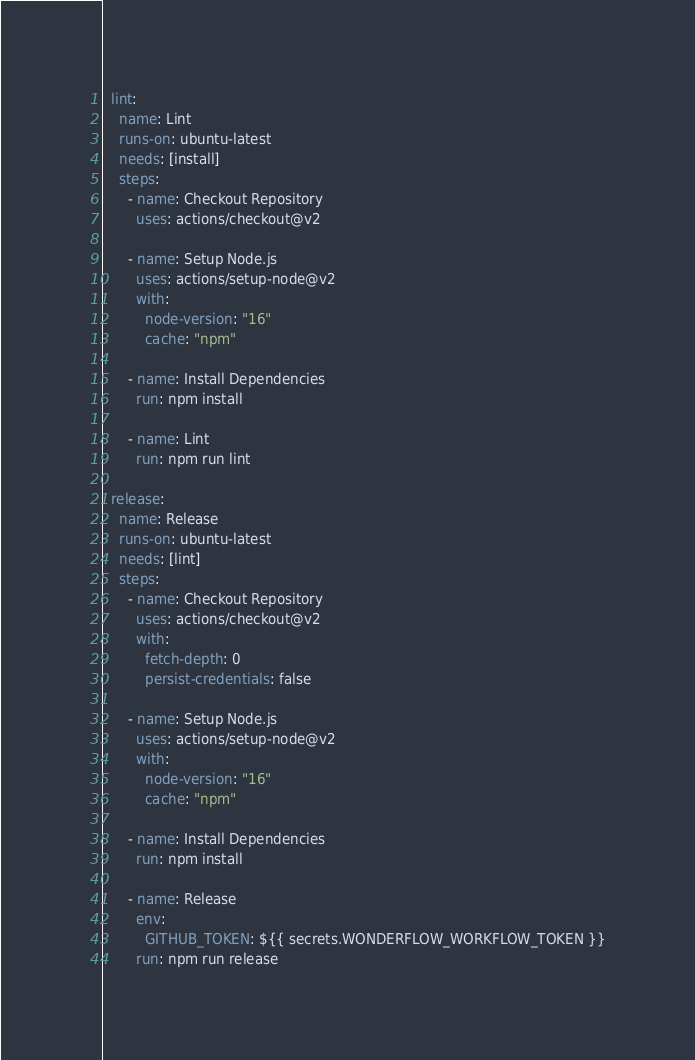<code> <loc_0><loc_0><loc_500><loc_500><_YAML_>  lint:
    name: Lint
    runs-on: ubuntu-latest
    needs: [install]
    steps:
      - name: Checkout Repository
        uses: actions/checkout@v2

      - name: Setup Node.js
        uses: actions/setup-node@v2
        with:
          node-version: "16"
          cache: "npm"

      - name: Install Dependencies
        run: npm install

      - name: Lint
        run: npm run lint

  release:
    name: Release
    runs-on: ubuntu-latest
    needs: [lint]
    steps:
      - name: Checkout Repository
        uses: actions/checkout@v2
        with:
          fetch-depth: 0
          persist-credentials: false

      - name: Setup Node.js
        uses: actions/setup-node@v2
        with:
          node-version: "16"
          cache: "npm"

      - name: Install Dependencies
        run: npm install

      - name: Release
        env:
          GITHUB_TOKEN: ${{ secrets.WONDERFLOW_WORKFLOW_TOKEN }}
        run: npm run release
</code> 